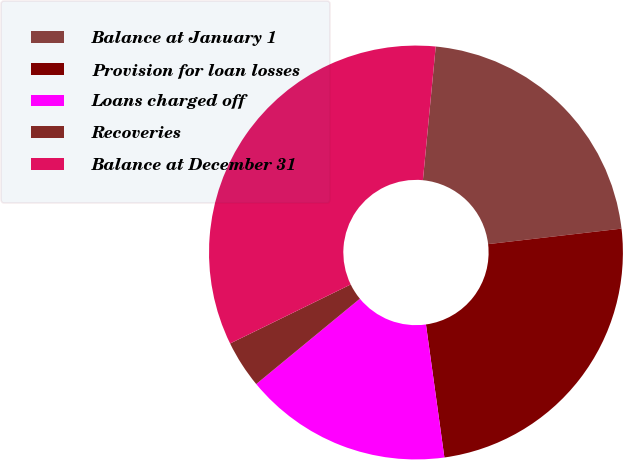Convert chart. <chart><loc_0><loc_0><loc_500><loc_500><pie_chart><fcel>Balance at January 1<fcel>Provision for loan losses<fcel>Loans charged off<fcel>Recoveries<fcel>Balance at December 31<nl><fcel>21.64%<fcel>24.65%<fcel>16.23%<fcel>3.72%<fcel>33.77%<nl></chart> 